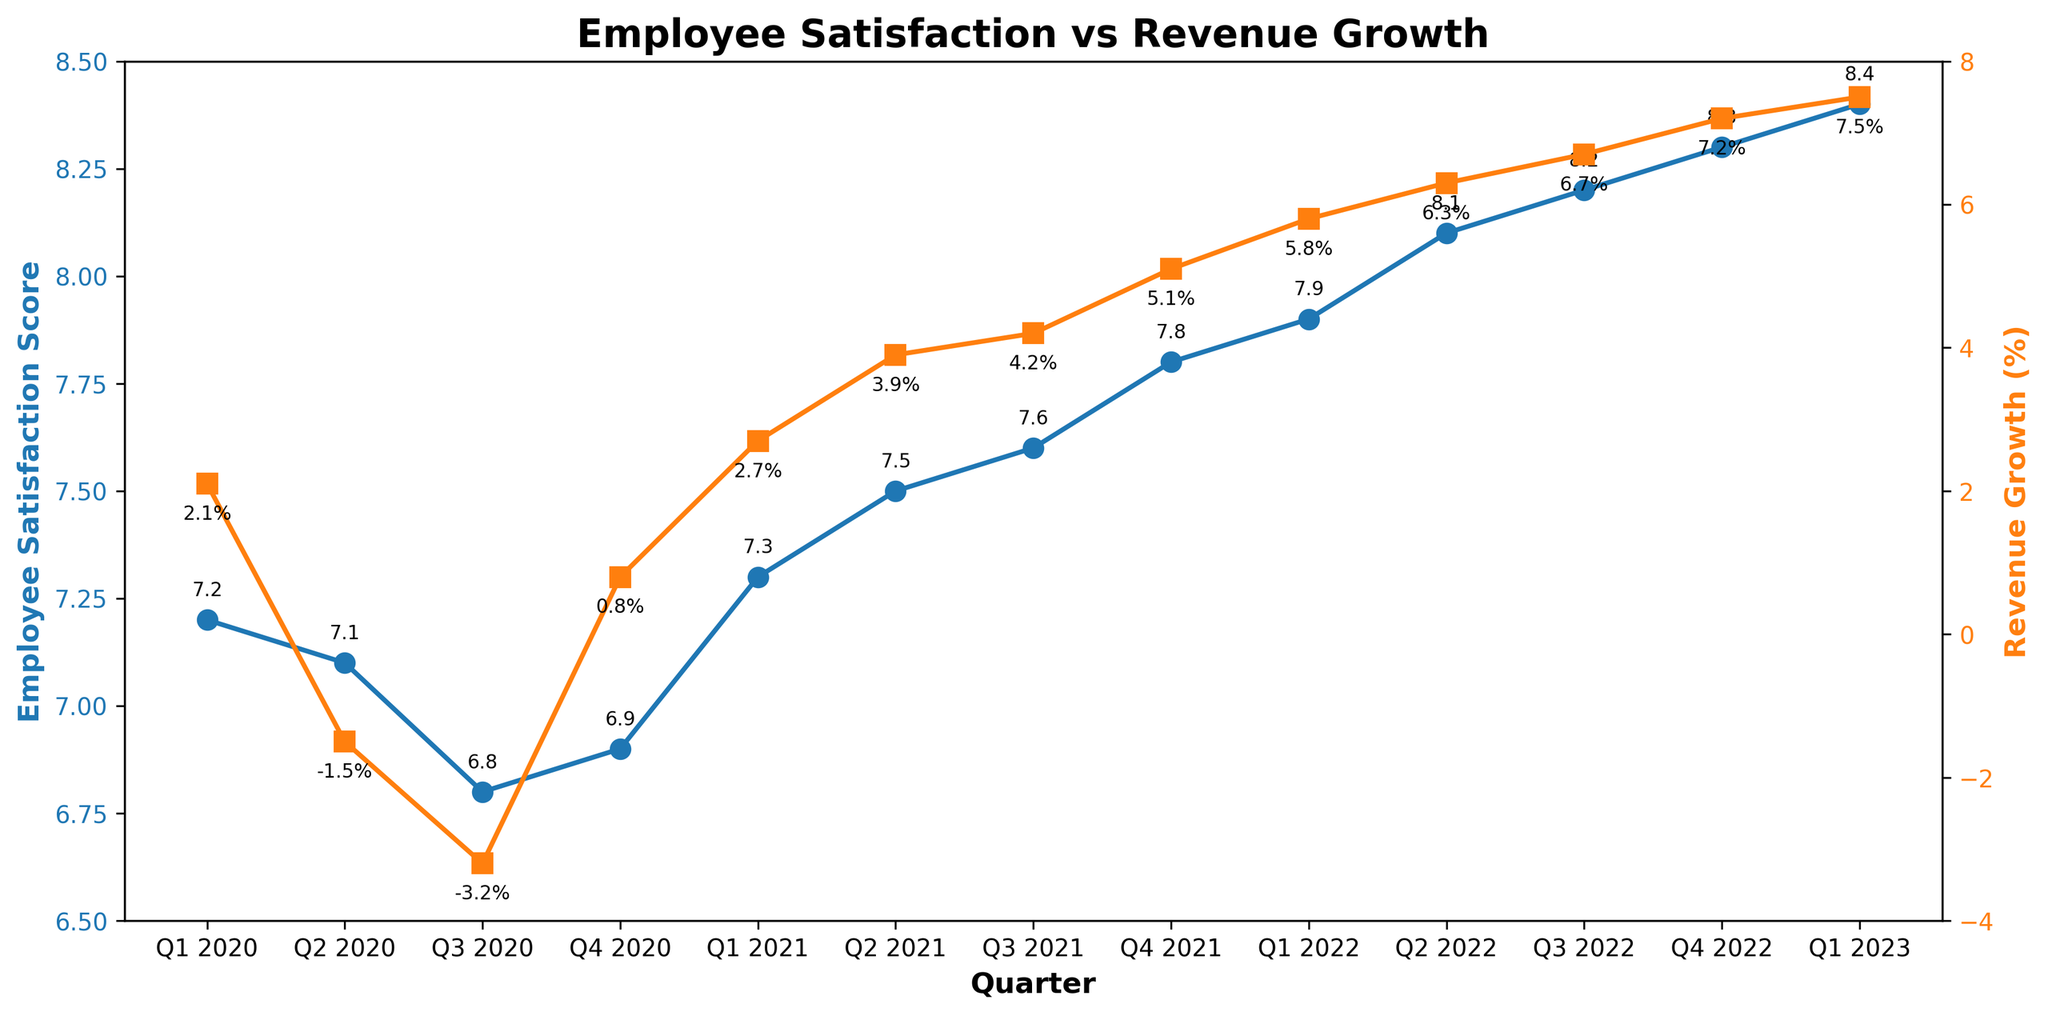What is the employee satisfaction score in Q1 2020 and Q1 2023? The employee satisfaction score for Q1 2020 can be observed from the plot as 7.2. Similarly, the score for Q1 2023 is seen as 8.4.
Answer: 7.2 and 8.4 How did revenue growth change from Q2 2020 to Q3 2020? According to the plot, revenue growth was -1.5% in Q2 2020 and decreased to -3.2% in Q3 2020. The change in revenue growth is -3.2% - (-1.5%) = -1.7%.
Answer: -1.7% In which quarter was the employee satisfaction score the highest? From the plot, the highest employee satisfaction score is in Q1 2023, with a score of 8.4.
Answer: Q1 2023 What is the difference in employee satisfaction scores between Q4 2020 and Q4 2022? The plot shows that the employee satisfaction score was 6.9 in Q4 2020 and 8.3 in Q4 2022. Therefore, the difference is 8.3 - 6.9 = 1.4.
Answer: 1.4 Which quarter experienced the greatest increase in revenue growth, and by how much? By examining the plot, the greatest increase in revenue growth occurs between Q4 2021 (5.1%) and Q1 2022 (5.8%). The increase is 5.8% - 5.1% = 0.7%.
Answer: Q1 2022, 0.7% Between Q2 2021 and Q3 2021, did the employee satisfaction score increase or decrease, and by how much? The plot shows that the employee satisfaction score increased from 7.5 in Q2 2021 to 7.6 in Q3 2021. The increase is 7.6 - 7.5 = 0.1.
Answer: Increase, 0.1 What is the average revenue growth rate for the year 2022? The revenue growth rates for Q1, Q2, Q3, and Q4 of 2022 are 5.8%, 6.3%, 6.7%, and 7.2% respectively. The average is (5.8 + 6.3 + 6.7 + 7.2) / 4 = 6.5%.
Answer: 6.5% In which year did revenue growth trend positively every quarter? The plot shows that revenue growth was consistently positive in each quarter of 2022.
Answer: 2022 What is the cumulative employee satisfaction score for all quarters in 2021? The employee satisfaction scores for Q1, Q2, Q3, and Q4 of 2021 are 7.3, 7.5, 7.6, and 7.8 respectively. The cumulative score is 7.3 + 7.5 + 7.6 + 7.8 = 30.2.
Answer: 30.2 Compare the trend of employee satisfaction scores and revenue growth from Q1 2020 to Q4 2021. Do they move in the same direction? From Q1 2020 to Q4 2021, employee satisfaction scores show a positive trend overall, increasing from 7.2 to 7.8. On the other hand, revenue growth fluctuates initially but follows a positive trend from -3.2% in Q3 2020 to 5.1% in Q4 2021. Therefore, they move in the same direction towards the end of the period.
Answer: Yes 